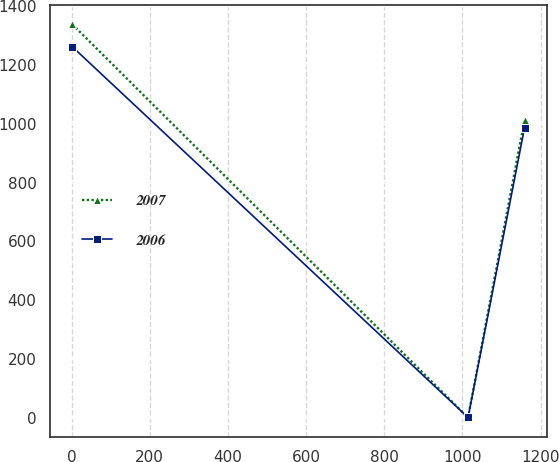<chart> <loc_0><loc_0><loc_500><loc_500><line_chart><ecel><fcel>2007<fcel>2006<nl><fcel>1.9<fcel>1336.91<fcel>1260.9<nl><fcel>1014.39<fcel>1.99<fcel>2.58<nl><fcel>1158.88<fcel>1012<fcel>985.87<nl></chart> 